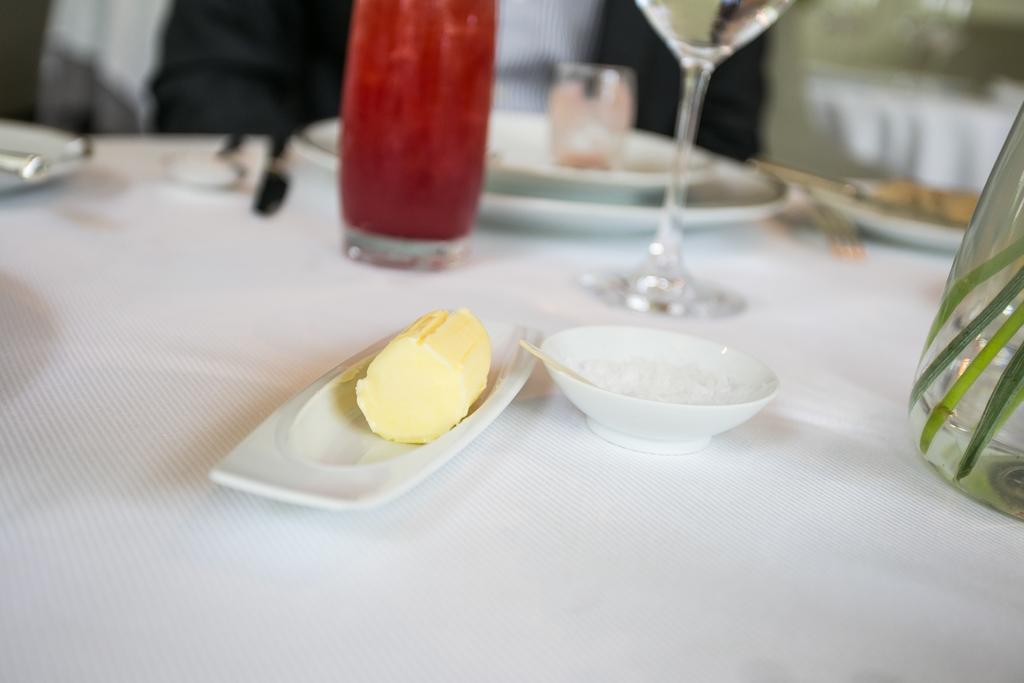Can you describe this image briefly? Here in this picture we can see a table and a bowl and a plate and a bottle and a glass placed on it and there is spoon and butter knife also 